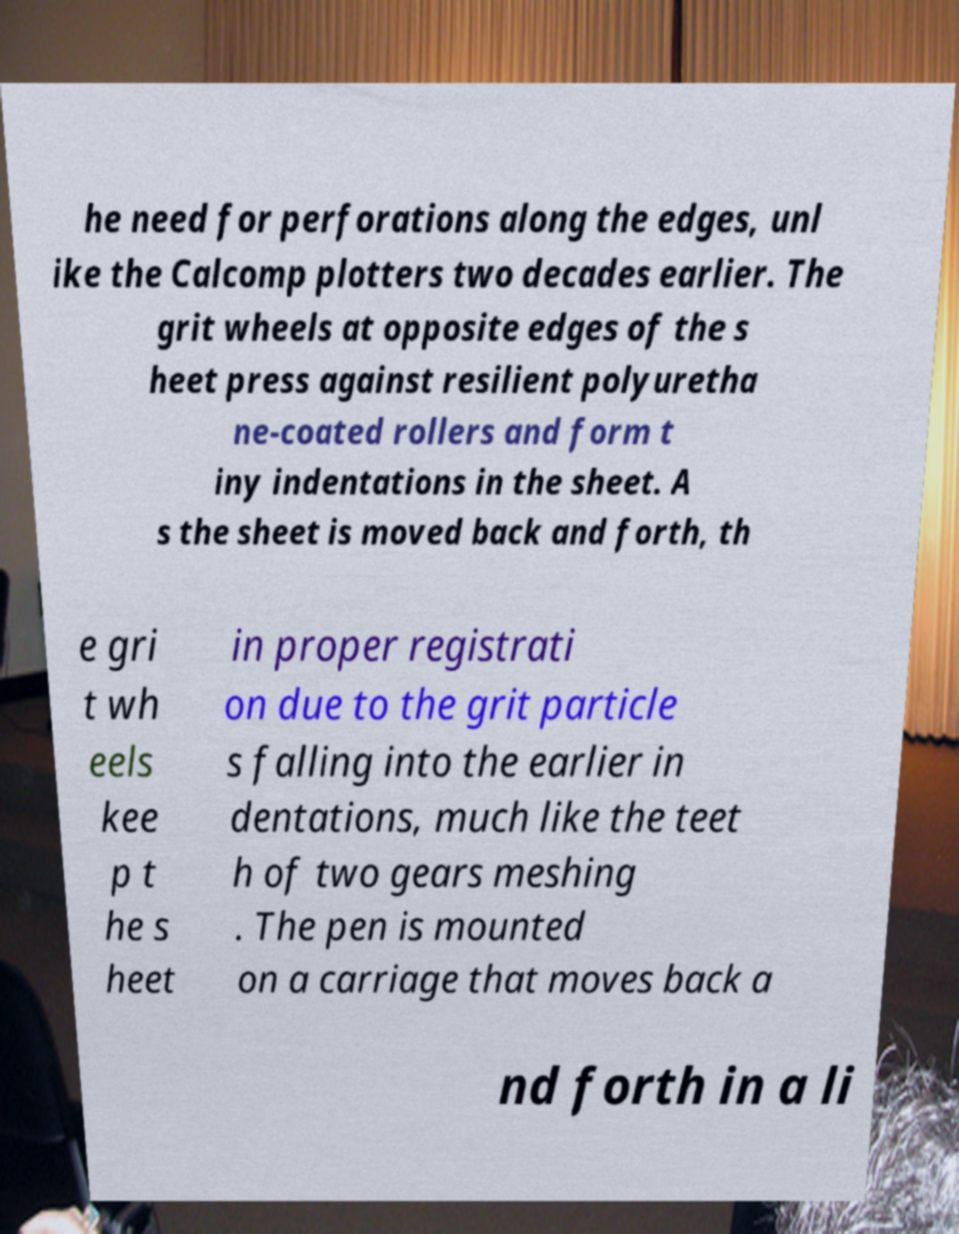For documentation purposes, I need the text within this image transcribed. Could you provide that? he need for perforations along the edges, unl ike the Calcomp plotters two decades earlier. The grit wheels at opposite edges of the s heet press against resilient polyuretha ne-coated rollers and form t iny indentations in the sheet. A s the sheet is moved back and forth, th e gri t wh eels kee p t he s heet in proper registrati on due to the grit particle s falling into the earlier in dentations, much like the teet h of two gears meshing . The pen is mounted on a carriage that moves back a nd forth in a li 